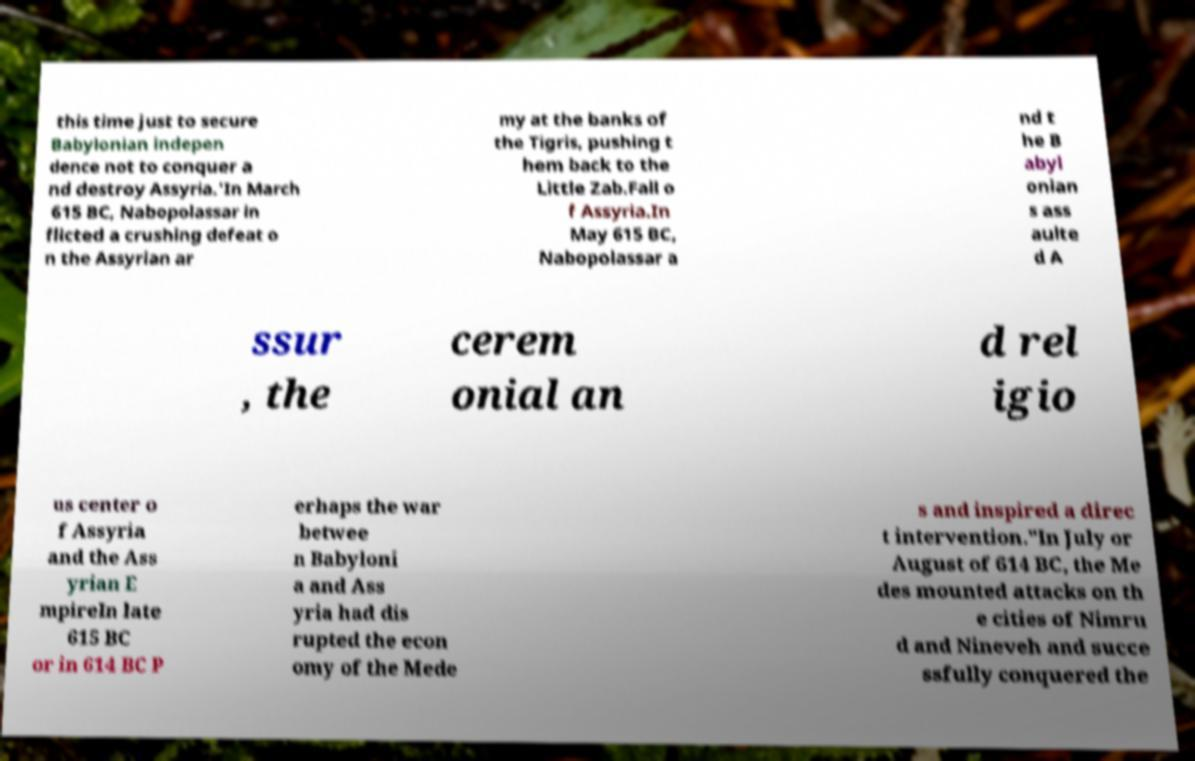There's text embedded in this image that I need extracted. Can you transcribe it verbatim? this time just to secure Babylonian indepen dence not to conquer a nd destroy Assyria.'In March 615 BC, Nabopolassar in flicted a crushing defeat o n the Assyrian ar my at the banks of the Tigris, pushing t hem back to the Little Zab.Fall o f Assyria.In May 615 BC, Nabopolassar a nd t he B abyl onian s ass aulte d A ssur , the cerem onial an d rel igio us center o f Assyria and the Ass yrian E mpireIn late 615 BC or in 614 BC P erhaps the war betwee n Babyloni a and Ass yria had dis rupted the econ omy of the Mede s and inspired a direc t intervention."In July or August of 614 BC, the Me des mounted attacks on th e cities of Nimru d and Nineveh and succe ssfully conquered the 